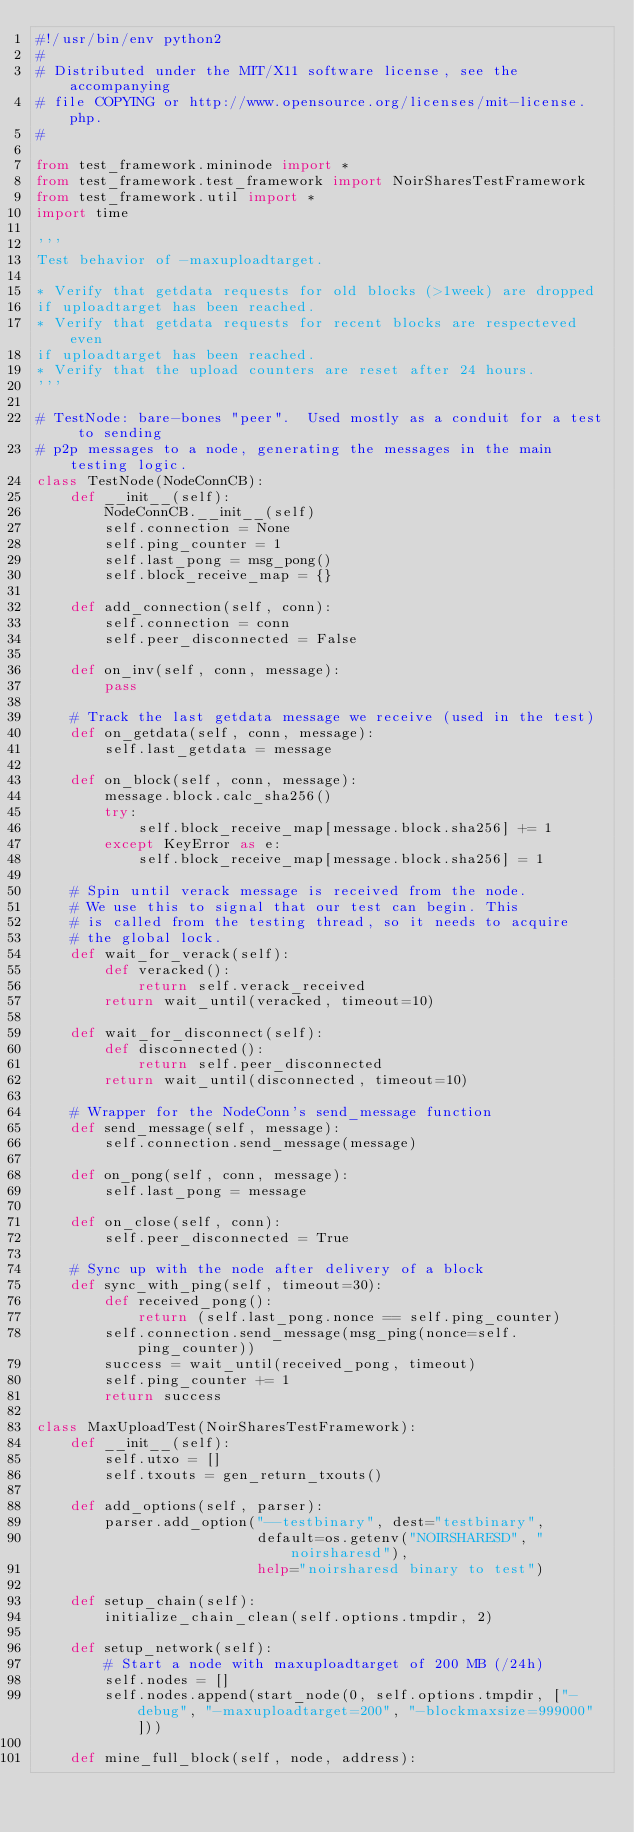Convert code to text. <code><loc_0><loc_0><loc_500><loc_500><_Python_>#!/usr/bin/env python2
#
# Distributed under the MIT/X11 software license, see the accompanying
# file COPYING or http://www.opensource.org/licenses/mit-license.php.
#

from test_framework.mininode import *
from test_framework.test_framework import NoirSharesTestFramework
from test_framework.util import *
import time

'''
Test behavior of -maxuploadtarget.

* Verify that getdata requests for old blocks (>1week) are dropped
if uploadtarget has been reached.
* Verify that getdata requests for recent blocks are respecteved even
if uploadtarget has been reached.
* Verify that the upload counters are reset after 24 hours.
'''

# TestNode: bare-bones "peer".  Used mostly as a conduit for a test to sending
# p2p messages to a node, generating the messages in the main testing logic.
class TestNode(NodeConnCB):
    def __init__(self):
        NodeConnCB.__init__(self)
        self.connection = None
        self.ping_counter = 1
        self.last_pong = msg_pong()
        self.block_receive_map = {}

    def add_connection(self, conn):
        self.connection = conn
        self.peer_disconnected = False

    def on_inv(self, conn, message):
        pass

    # Track the last getdata message we receive (used in the test)
    def on_getdata(self, conn, message):
        self.last_getdata = message

    def on_block(self, conn, message):
        message.block.calc_sha256()
        try:
            self.block_receive_map[message.block.sha256] += 1
        except KeyError as e:
            self.block_receive_map[message.block.sha256] = 1

    # Spin until verack message is received from the node.
    # We use this to signal that our test can begin. This
    # is called from the testing thread, so it needs to acquire
    # the global lock.
    def wait_for_verack(self):
        def veracked():
            return self.verack_received
        return wait_until(veracked, timeout=10)

    def wait_for_disconnect(self):
        def disconnected():
            return self.peer_disconnected
        return wait_until(disconnected, timeout=10)

    # Wrapper for the NodeConn's send_message function
    def send_message(self, message):
        self.connection.send_message(message)

    def on_pong(self, conn, message):
        self.last_pong = message

    def on_close(self, conn):
        self.peer_disconnected = True

    # Sync up with the node after delivery of a block
    def sync_with_ping(self, timeout=30):
        def received_pong():
            return (self.last_pong.nonce == self.ping_counter)
        self.connection.send_message(msg_ping(nonce=self.ping_counter))
        success = wait_until(received_pong, timeout)
        self.ping_counter += 1
        return success

class MaxUploadTest(NoirSharesTestFramework):
    def __init__(self):
        self.utxo = []
        self.txouts = gen_return_txouts()
 
    def add_options(self, parser):
        parser.add_option("--testbinary", dest="testbinary",
                          default=os.getenv("NOIRSHARESD", "noirsharesd"),
                          help="noirsharesd binary to test")

    def setup_chain(self):
        initialize_chain_clean(self.options.tmpdir, 2)

    def setup_network(self):
        # Start a node with maxuploadtarget of 200 MB (/24h)
        self.nodes = []
        self.nodes.append(start_node(0, self.options.tmpdir, ["-debug", "-maxuploadtarget=200", "-blockmaxsize=999000"]))

    def mine_full_block(self, node, address):</code> 